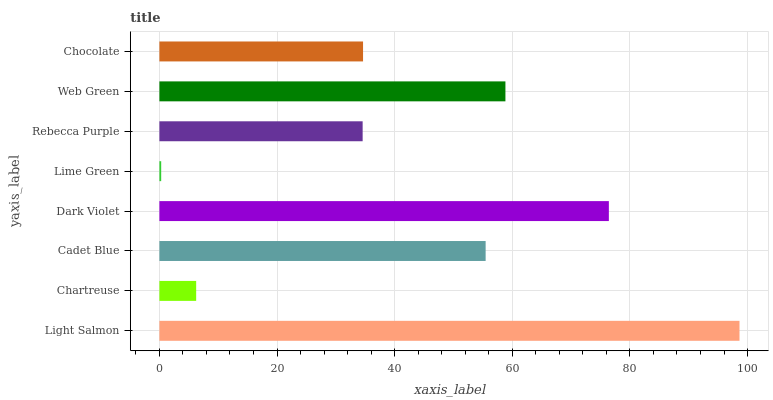Is Lime Green the minimum?
Answer yes or no. Yes. Is Light Salmon the maximum?
Answer yes or no. Yes. Is Chartreuse the minimum?
Answer yes or no. No. Is Chartreuse the maximum?
Answer yes or no. No. Is Light Salmon greater than Chartreuse?
Answer yes or no. Yes. Is Chartreuse less than Light Salmon?
Answer yes or no. Yes. Is Chartreuse greater than Light Salmon?
Answer yes or no. No. Is Light Salmon less than Chartreuse?
Answer yes or no. No. Is Cadet Blue the high median?
Answer yes or no. Yes. Is Chocolate the low median?
Answer yes or no. Yes. Is Dark Violet the high median?
Answer yes or no. No. Is Rebecca Purple the low median?
Answer yes or no. No. 